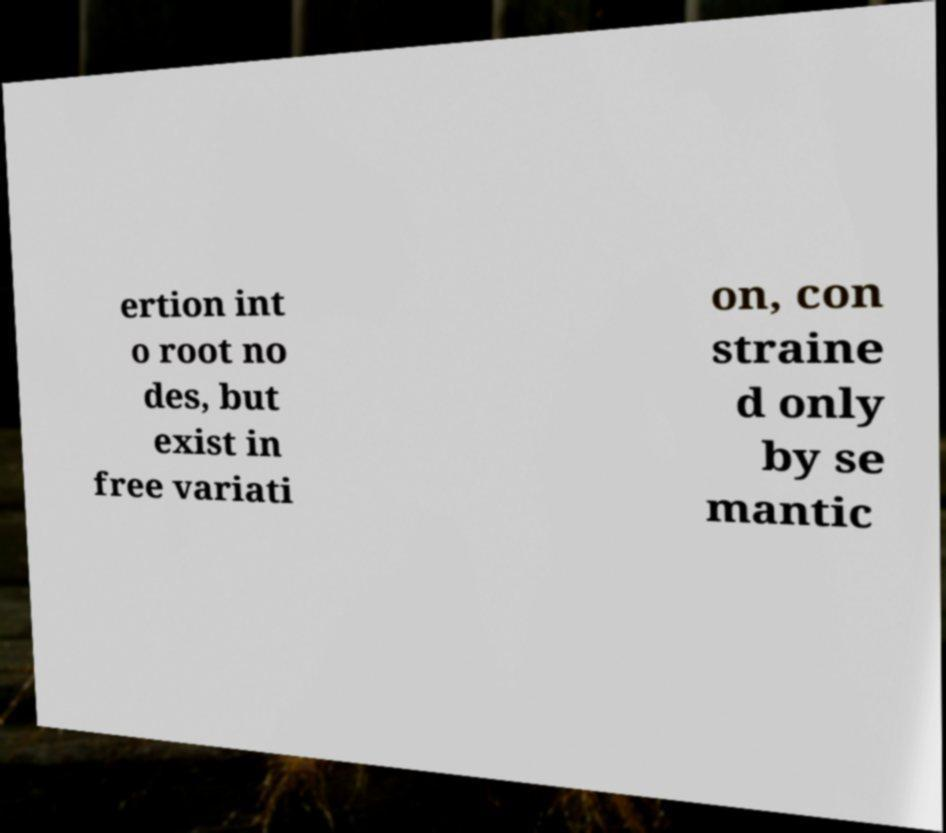Can you read and provide the text displayed in the image?This photo seems to have some interesting text. Can you extract and type it out for me? ertion int o root no des, but exist in free variati on, con straine d only by se mantic 